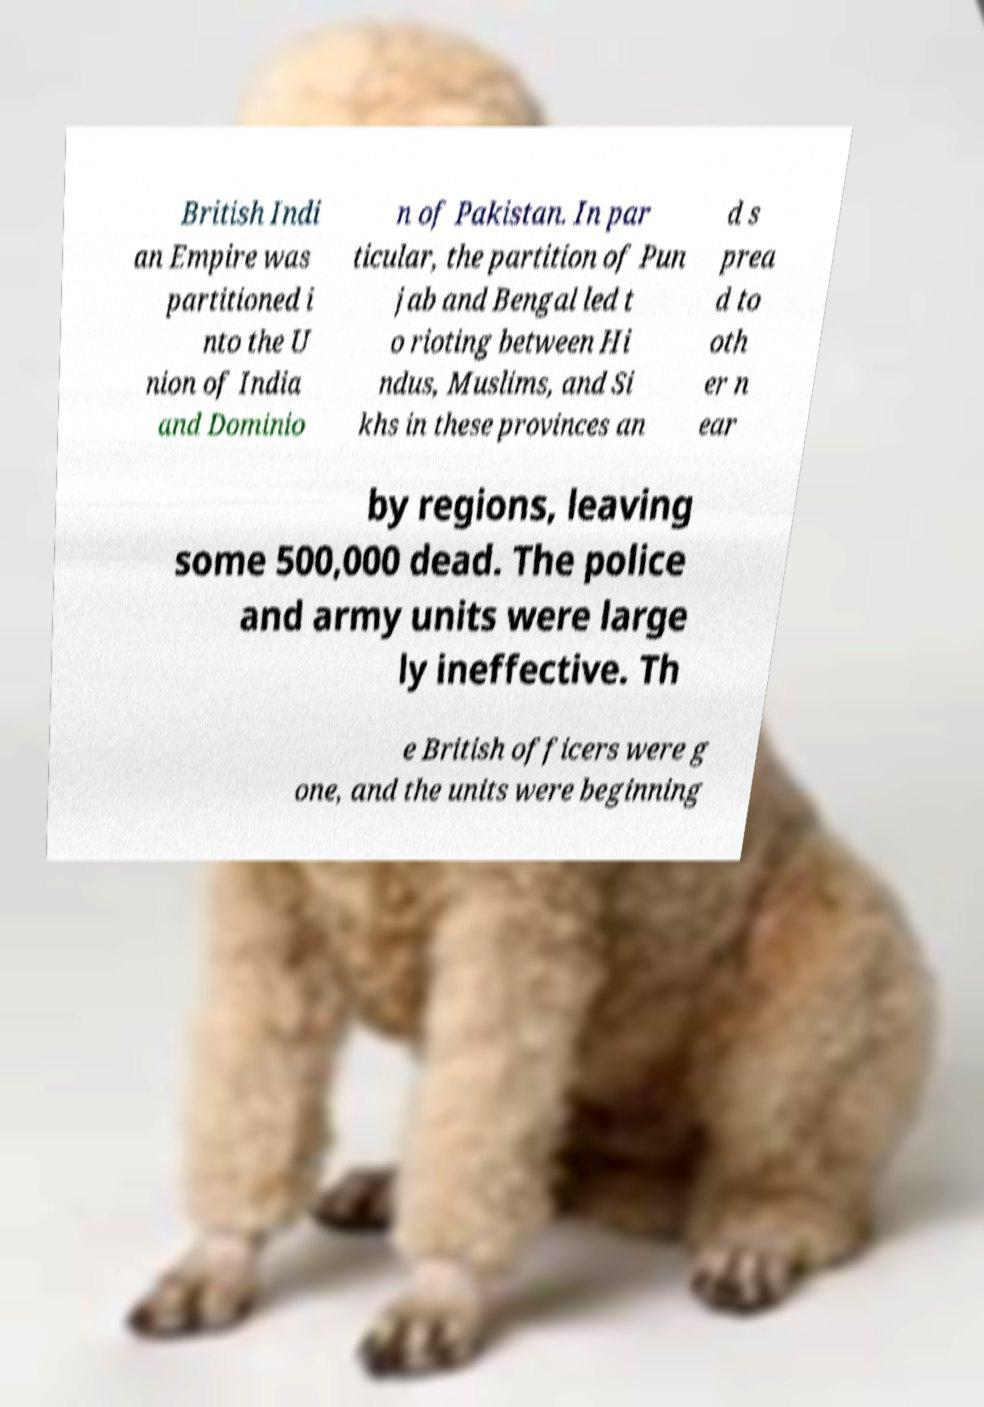Please read and relay the text visible in this image. What does it say? British Indi an Empire was partitioned i nto the U nion of India and Dominio n of Pakistan. In par ticular, the partition of Pun jab and Bengal led t o rioting between Hi ndus, Muslims, and Si khs in these provinces an d s prea d to oth er n ear by regions, leaving some 500,000 dead. The police and army units were large ly ineffective. Th e British officers were g one, and the units were beginning 